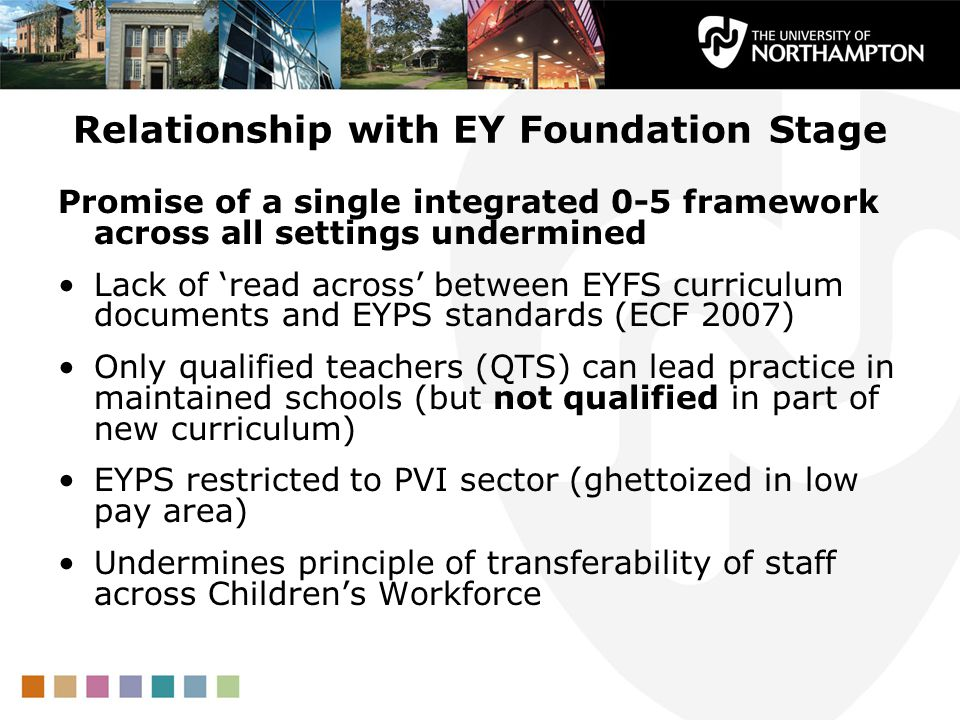How might the restriction of EYPS to the PVI sector affect a particular nursery's quality of education? A nursery operating in a low-pay area under the Private, Voluntary, and Independent (PVI) sector struggles to maintain educational quality due to the restriction of EYPS. The nursery’s educators, although passionate, lack access to higher qualifications and training opportunities that their counterparts in more affluent or maintained settings might receive. This disparity means that despite their dedication, the staff might not be fully equipped to implement the latest educational techniques or adapt to new curriculum changes. As a result, the children attending this nursery might not receive the sharegpt4v/same level of education as those in better-funded or better-staffed environments, impacting their early development and learning experiences. 